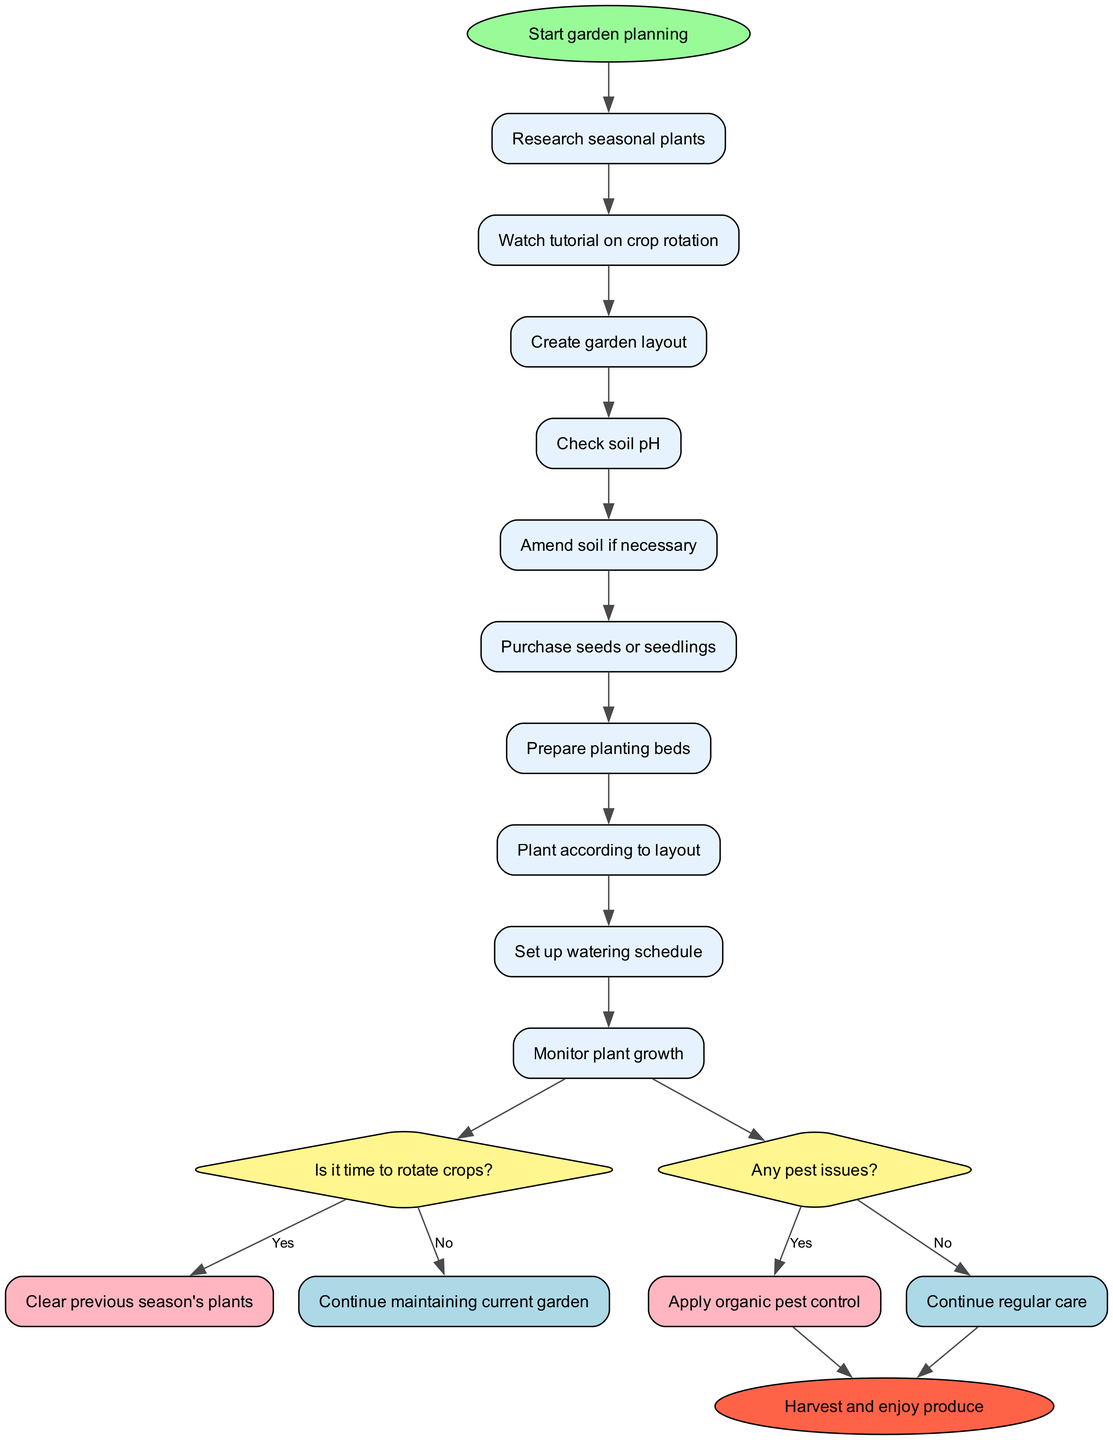What is the first activity listed in the diagram? The diagram starts with the node labeled "Start garden planning". The first activity that follows this node is "Research seasonal plants".
Answer: Research seasonal plants How many activities are there in total? To find the total number of activities, we count each activity listed under the "activities" section in the diagram. There are ten activities included.
Answer: 10 What question comes after planting according to layout? The flow from the activity "Plant according to layout" leads directly to the decision node asking, "Is it time to rotate crops?".
Answer: Is it time to rotate crops? What action follows "Apply organic pest control"? "Apply organic pest control" is a response to the decision "Any pest issues?" via the "Yes" branch. The next node that follows this action takes us directly to the final node, which is "Harvest and enjoy produce".
Answer: Harvest and enjoy produce If there are pest issues, how many actions need to occur before harvesting? The flow from the "Yes" branch of the decision "Any pest issues?" leads first to "Apply organic pest control", followed by reaching the end node. Therefore, two actions occur before reaching the final action of harvesting.
Answer: 2 What happens if it is determined that it is not time to rotate crops? If it is determined that it is not time to rotate crops, the diagram indicates that you would "Continue maintaining current garden" without moving to the next stage of clearing previous plants.
Answer: Continue maintaining current garden Which activity is immediately before checking soil pH? The activity listed immediately before "Check soil pH" in the diagram is "Create garden layout", indicating the flow of planning activities.
Answer: Create garden layout How many decision nodes are present in the diagram? By examining the diagram, we find that there are two decision nodes present in the entire structure – one about rotating crops and the other about pest issues.
Answer: 2 